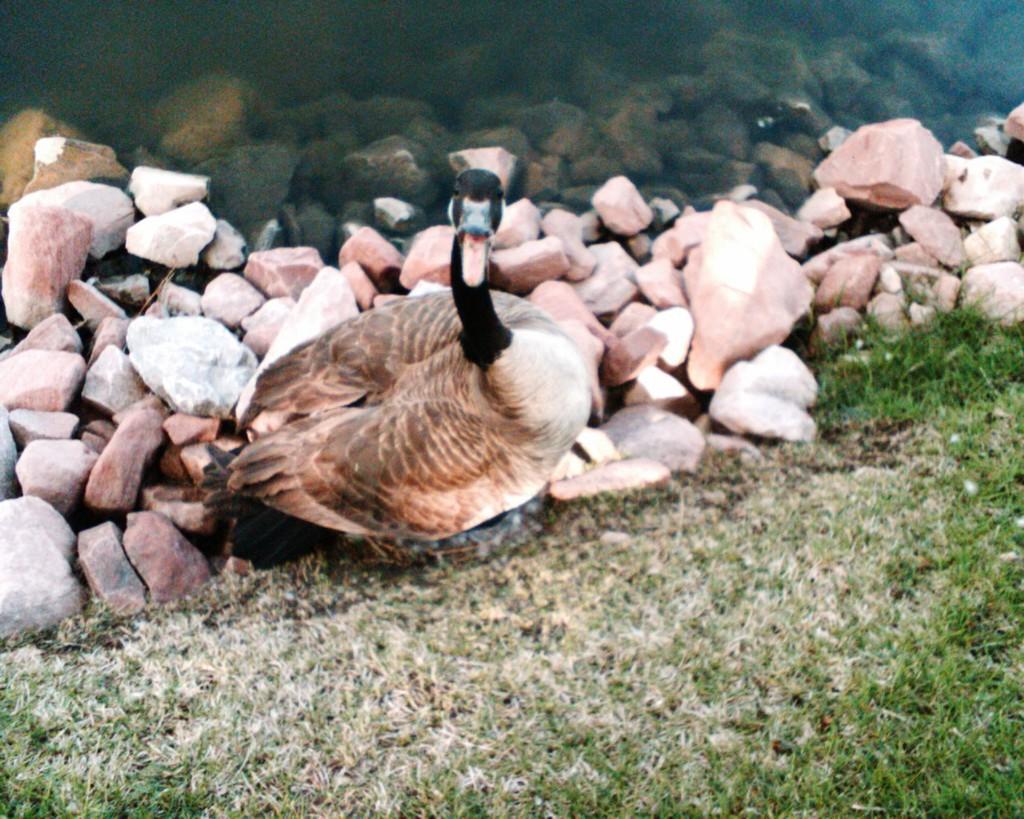In one or two sentences, can you explain what this image depicts? Here we can see water, rocks, duck and grass.  